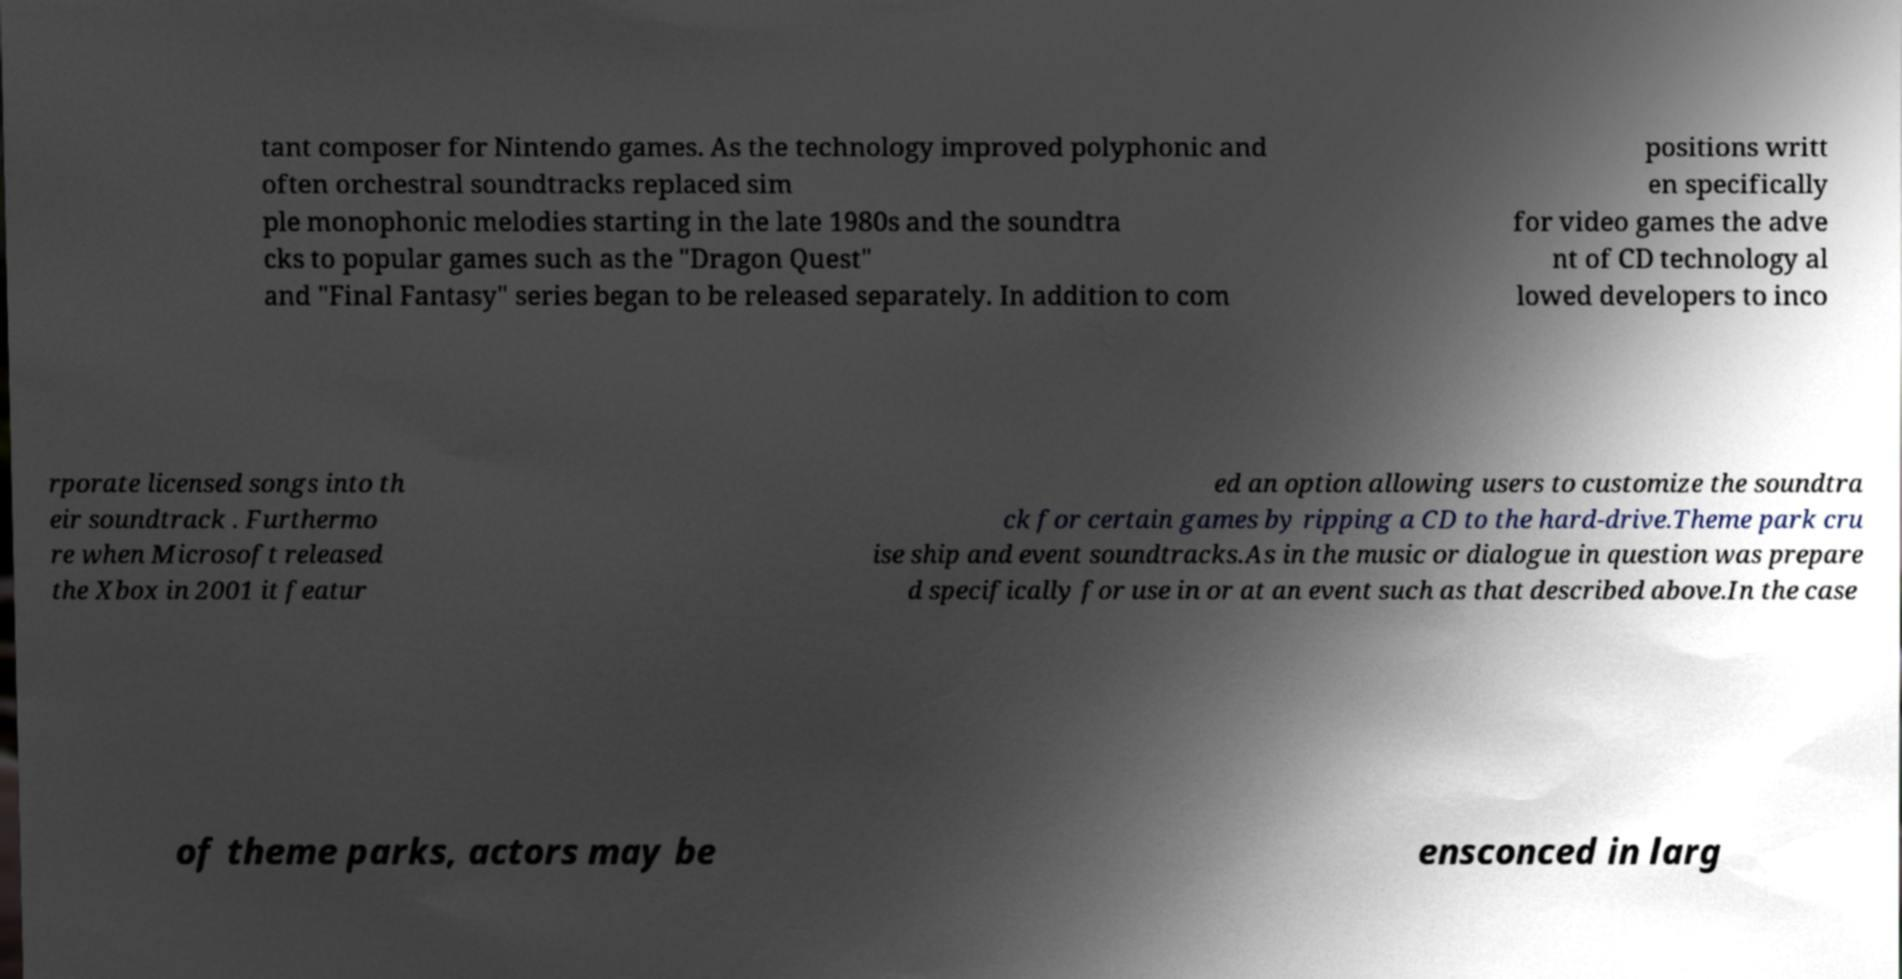Could you assist in decoding the text presented in this image and type it out clearly? tant composer for Nintendo games. As the technology improved polyphonic and often orchestral soundtracks replaced sim ple monophonic melodies starting in the late 1980s and the soundtra cks to popular games such as the "Dragon Quest" and "Final Fantasy" series began to be released separately. In addition to com positions writt en specifically for video games the adve nt of CD technology al lowed developers to inco rporate licensed songs into th eir soundtrack . Furthermo re when Microsoft released the Xbox in 2001 it featur ed an option allowing users to customize the soundtra ck for certain games by ripping a CD to the hard-drive.Theme park cru ise ship and event soundtracks.As in the music or dialogue in question was prepare d specifically for use in or at an event such as that described above.In the case of theme parks, actors may be ensconced in larg 